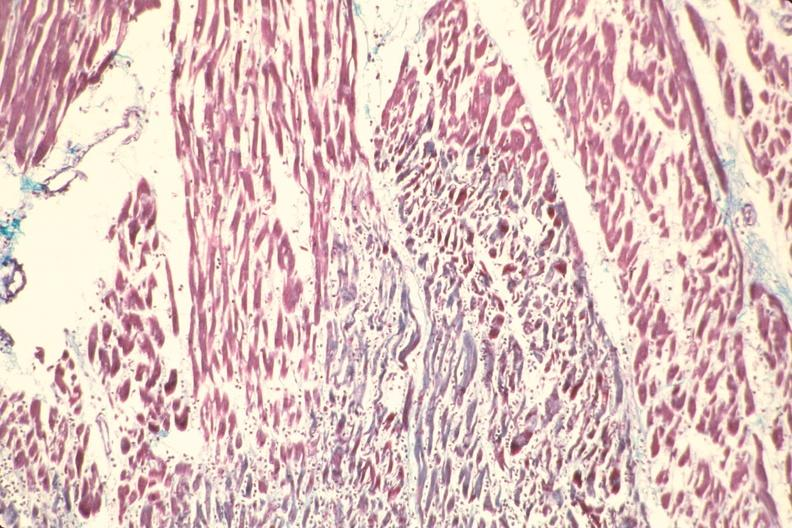what stain?
Answer the question using a single word or phrase. Aldehyde fuscin 